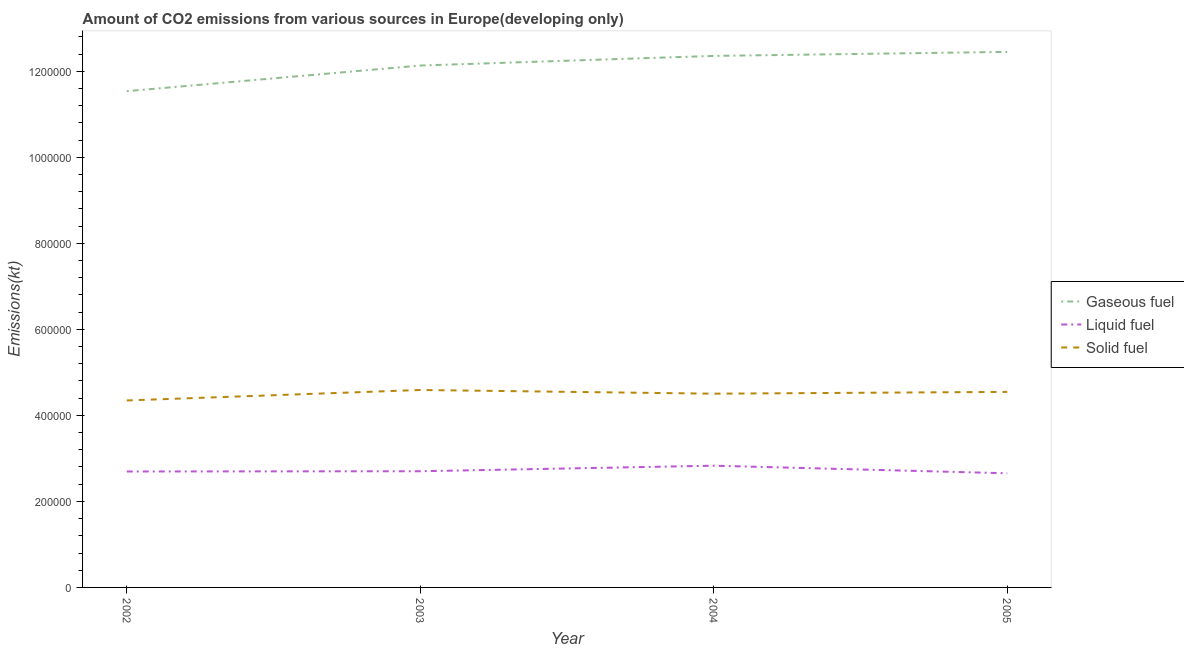Is the number of lines equal to the number of legend labels?
Make the answer very short. Yes. What is the amount of co2 emissions from solid fuel in 2004?
Your response must be concise. 4.50e+05. Across all years, what is the maximum amount of co2 emissions from liquid fuel?
Ensure brevity in your answer.  2.83e+05. Across all years, what is the minimum amount of co2 emissions from solid fuel?
Offer a very short reply. 4.35e+05. In which year was the amount of co2 emissions from solid fuel maximum?
Your answer should be very brief. 2003. What is the total amount of co2 emissions from liquid fuel in the graph?
Your answer should be very brief. 1.09e+06. What is the difference between the amount of co2 emissions from liquid fuel in 2002 and that in 2005?
Offer a terse response. 4170.8. What is the difference between the amount of co2 emissions from gaseous fuel in 2004 and the amount of co2 emissions from solid fuel in 2002?
Your answer should be very brief. 8.01e+05. What is the average amount of co2 emissions from solid fuel per year?
Make the answer very short. 4.50e+05. In the year 2005, what is the difference between the amount of co2 emissions from solid fuel and amount of co2 emissions from liquid fuel?
Give a very brief answer. 1.89e+05. What is the ratio of the amount of co2 emissions from solid fuel in 2004 to that in 2005?
Provide a succinct answer. 0.99. Is the amount of co2 emissions from liquid fuel in 2003 less than that in 2005?
Offer a very short reply. No. Is the difference between the amount of co2 emissions from solid fuel in 2004 and 2005 greater than the difference between the amount of co2 emissions from liquid fuel in 2004 and 2005?
Make the answer very short. No. What is the difference between the highest and the second highest amount of co2 emissions from solid fuel?
Offer a terse response. 4414.18. What is the difference between the highest and the lowest amount of co2 emissions from gaseous fuel?
Offer a terse response. 9.13e+04. Is the amount of co2 emissions from solid fuel strictly greater than the amount of co2 emissions from liquid fuel over the years?
Provide a short and direct response. Yes. Is the amount of co2 emissions from liquid fuel strictly less than the amount of co2 emissions from solid fuel over the years?
Make the answer very short. Yes. What is the difference between two consecutive major ticks on the Y-axis?
Offer a terse response. 2.00e+05. Where does the legend appear in the graph?
Ensure brevity in your answer.  Center right. What is the title of the graph?
Your answer should be compact. Amount of CO2 emissions from various sources in Europe(developing only). Does "Other sectors" appear as one of the legend labels in the graph?
Provide a short and direct response. No. What is the label or title of the X-axis?
Your response must be concise. Year. What is the label or title of the Y-axis?
Your answer should be very brief. Emissions(kt). What is the Emissions(kt) of Gaseous fuel in 2002?
Offer a terse response. 1.15e+06. What is the Emissions(kt) of Liquid fuel in 2002?
Make the answer very short. 2.70e+05. What is the Emissions(kt) in Solid fuel in 2002?
Offer a terse response. 4.35e+05. What is the Emissions(kt) of Gaseous fuel in 2003?
Keep it short and to the point. 1.21e+06. What is the Emissions(kt) in Liquid fuel in 2003?
Offer a very short reply. 2.70e+05. What is the Emissions(kt) of Solid fuel in 2003?
Make the answer very short. 4.59e+05. What is the Emissions(kt) of Gaseous fuel in 2004?
Keep it short and to the point. 1.24e+06. What is the Emissions(kt) in Liquid fuel in 2004?
Provide a short and direct response. 2.83e+05. What is the Emissions(kt) in Solid fuel in 2004?
Keep it short and to the point. 4.50e+05. What is the Emissions(kt) in Gaseous fuel in 2005?
Ensure brevity in your answer.  1.25e+06. What is the Emissions(kt) in Liquid fuel in 2005?
Give a very brief answer. 2.65e+05. What is the Emissions(kt) of Solid fuel in 2005?
Provide a short and direct response. 4.55e+05. Across all years, what is the maximum Emissions(kt) of Gaseous fuel?
Offer a very short reply. 1.25e+06. Across all years, what is the maximum Emissions(kt) of Liquid fuel?
Offer a very short reply. 2.83e+05. Across all years, what is the maximum Emissions(kt) of Solid fuel?
Make the answer very short. 4.59e+05. Across all years, what is the minimum Emissions(kt) in Gaseous fuel?
Your response must be concise. 1.15e+06. Across all years, what is the minimum Emissions(kt) of Liquid fuel?
Provide a short and direct response. 2.65e+05. Across all years, what is the minimum Emissions(kt) of Solid fuel?
Offer a very short reply. 4.35e+05. What is the total Emissions(kt) of Gaseous fuel in the graph?
Give a very brief answer. 4.85e+06. What is the total Emissions(kt) of Liquid fuel in the graph?
Ensure brevity in your answer.  1.09e+06. What is the total Emissions(kt) of Solid fuel in the graph?
Give a very brief answer. 1.80e+06. What is the difference between the Emissions(kt) in Gaseous fuel in 2002 and that in 2003?
Your answer should be compact. -5.96e+04. What is the difference between the Emissions(kt) in Liquid fuel in 2002 and that in 2003?
Keep it short and to the point. -564.24. What is the difference between the Emissions(kt) of Solid fuel in 2002 and that in 2003?
Give a very brief answer. -2.43e+04. What is the difference between the Emissions(kt) in Gaseous fuel in 2002 and that in 2004?
Give a very brief answer. -8.20e+04. What is the difference between the Emissions(kt) of Liquid fuel in 2002 and that in 2004?
Ensure brevity in your answer.  -1.35e+04. What is the difference between the Emissions(kt) in Solid fuel in 2002 and that in 2004?
Your answer should be compact. -1.58e+04. What is the difference between the Emissions(kt) of Gaseous fuel in 2002 and that in 2005?
Make the answer very short. -9.13e+04. What is the difference between the Emissions(kt) of Liquid fuel in 2002 and that in 2005?
Ensure brevity in your answer.  4170.8. What is the difference between the Emissions(kt) of Solid fuel in 2002 and that in 2005?
Offer a very short reply. -1.99e+04. What is the difference between the Emissions(kt) of Gaseous fuel in 2003 and that in 2004?
Make the answer very short. -2.24e+04. What is the difference between the Emissions(kt) in Liquid fuel in 2003 and that in 2004?
Provide a short and direct response. -1.29e+04. What is the difference between the Emissions(kt) of Solid fuel in 2003 and that in 2004?
Your answer should be very brief. 8589.65. What is the difference between the Emissions(kt) of Gaseous fuel in 2003 and that in 2005?
Offer a terse response. -3.17e+04. What is the difference between the Emissions(kt) of Liquid fuel in 2003 and that in 2005?
Keep it short and to the point. 4735.04. What is the difference between the Emissions(kt) in Solid fuel in 2003 and that in 2005?
Provide a succinct answer. 4414.18. What is the difference between the Emissions(kt) in Gaseous fuel in 2004 and that in 2005?
Your response must be concise. -9315.59. What is the difference between the Emissions(kt) of Liquid fuel in 2004 and that in 2005?
Your answer should be very brief. 1.76e+04. What is the difference between the Emissions(kt) of Solid fuel in 2004 and that in 2005?
Offer a very short reply. -4175.47. What is the difference between the Emissions(kt) in Gaseous fuel in 2002 and the Emissions(kt) in Liquid fuel in 2003?
Give a very brief answer. 8.84e+05. What is the difference between the Emissions(kt) of Gaseous fuel in 2002 and the Emissions(kt) of Solid fuel in 2003?
Ensure brevity in your answer.  6.95e+05. What is the difference between the Emissions(kt) in Liquid fuel in 2002 and the Emissions(kt) in Solid fuel in 2003?
Offer a very short reply. -1.89e+05. What is the difference between the Emissions(kt) of Gaseous fuel in 2002 and the Emissions(kt) of Liquid fuel in 2004?
Offer a terse response. 8.71e+05. What is the difference between the Emissions(kt) in Gaseous fuel in 2002 and the Emissions(kt) in Solid fuel in 2004?
Ensure brevity in your answer.  7.03e+05. What is the difference between the Emissions(kt) of Liquid fuel in 2002 and the Emissions(kt) of Solid fuel in 2004?
Offer a terse response. -1.81e+05. What is the difference between the Emissions(kt) of Gaseous fuel in 2002 and the Emissions(kt) of Liquid fuel in 2005?
Your answer should be compact. 8.88e+05. What is the difference between the Emissions(kt) in Gaseous fuel in 2002 and the Emissions(kt) in Solid fuel in 2005?
Provide a short and direct response. 6.99e+05. What is the difference between the Emissions(kt) in Liquid fuel in 2002 and the Emissions(kt) in Solid fuel in 2005?
Provide a short and direct response. -1.85e+05. What is the difference between the Emissions(kt) of Gaseous fuel in 2003 and the Emissions(kt) of Liquid fuel in 2004?
Your response must be concise. 9.30e+05. What is the difference between the Emissions(kt) in Gaseous fuel in 2003 and the Emissions(kt) in Solid fuel in 2004?
Offer a very short reply. 7.63e+05. What is the difference between the Emissions(kt) of Liquid fuel in 2003 and the Emissions(kt) of Solid fuel in 2004?
Your answer should be very brief. -1.80e+05. What is the difference between the Emissions(kt) in Gaseous fuel in 2003 and the Emissions(kt) in Liquid fuel in 2005?
Your answer should be compact. 9.48e+05. What is the difference between the Emissions(kt) in Gaseous fuel in 2003 and the Emissions(kt) in Solid fuel in 2005?
Make the answer very short. 7.59e+05. What is the difference between the Emissions(kt) in Liquid fuel in 2003 and the Emissions(kt) in Solid fuel in 2005?
Offer a terse response. -1.84e+05. What is the difference between the Emissions(kt) of Gaseous fuel in 2004 and the Emissions(kt) of Liquid fuel in 2005?
Ensure brevity in your answer.  9.70e+05. What is the difference between the Emissions(kt) in Gaseous fuel in 2004 and the Emissions(kt) in Solid fuel in 2005?
Offer a terse response. 7.81e+05. What is the difference between the Emissions(kt) in Liquid fuel in 2004 and the Emissions(kt) in Solid fuel in 2005?
Offer a very short reply. -1.72e+05. What is the average Emissions(kt) in Gaseous fuel per year?
Offer a terse response. 1.21e+06. What is the average Emissions(kt) of Liquid fuel per year?
Keep it short and to the point. 2.72e+05. What is the average Emissions(kt) of Solid fuel per year?
Give a very brief answer. 4.50e+05. In the year 2002, what is the difference between the Emissions(kt) of Gaseous fuel and Emissions(kt) of Liquid fuel?
Ensure brevity in your answer.  8.84e+05. In the year 2002, what is the difference between the Emissions(kt) in Gaseous fuel and Emissions(kt) in Solid fuel?
Provide a short and direct response. 7.19e+05. In the year 2002, what is the difference between the Emissions(kt) in Liquid fuel and Emissions(kt) in Solid fuel?
Ensure brevity in your answer.  -1.65e+05. In the year 2003, what is the difference between the Emissions(kt) in Gaseous fuel and Emissions(kt) in Liquid fuel?
Your answer should be compact. 9.43e+05. In the year 2003, what is the difference between the Emissions(kt) in Gaseous fuel and Emissions(kt) in Solid fuel?
Provide a succinct answer. 7.54e+05. In the year 2003, what is the difference between the Emissions(kt) in Liquid fuel and Emissions(kt) in Solid fuel?
Keep it short and to the point. -1.89e+05. In the year 2004, what is the difference between the Emissions(kt) of Gaseous fuel and Emissions(kt) of Liquid fuel?
Provide a succinct answer. 9.53e+05. In the year 2004, what is the difference between the Emissions(kt) of Gaseous fuel and Emissions(kt) of Solid fuel?
Make the answer very short. 7.85e+05. In the year 2004, what is the difference between the Emissions(kt) of Liquid fuel and Emissions(kt) of Solid fuel?
Provide a short and direct response. -1.67e+05. In the year 2005, what is the difference between the Emissions(kt) in Gaseous fuel and Emissions(kt) in Liquid fuel?
Offer a very short reply. 9.80e+05. In the year 2005, what is the difference between the Emissions(kt) of Gaseous fuel and Emissions(kt) of Solid fuel?
Offer a terse response. 7.90e+05. In the year 2005, what is the difference between the Emissions(kt) in Liquid fuel and Emissions(kt) in Solid fuel?
Keep it short and to the point. -1.89e+05. What is the ratio of the Emissions(kt) in Gaseous fuel in 2002 to that in 2003?
Your response must be concise. 0.95. What is the ratio of the Emissions(kt) of Solid fuel in 2002 to that in 2003?
Make the answer very short. 0.95. What is the ratio of the Emissions(kt) in Gaseous fuel in 2002 to that in 2004?
Keep it short and to the point. 0.93. What is the ratio of the Emissions(kt) in Liquid fuel in 2002 to that in 2004?
Provide a short and direct response. 0.95. What is the ratio of the Emissions(kt) in Solid fuel in 2002 to that in 2004?
Offer a terse response. 0.96. What is the ratio of the Emissions(kt) of Gaseous fuel in 2002 to that in 2005?
Offer a terse response. 0.93. What is the ratio of the Emissions(kt) in Liquid fuel in 2002 to that in 2005?
Ensure brevity in your answer.  1.02. What is the ratio of the Emissions(kt) of Solid fuel in 2002 to that in 2005?
Your answer should be compact. 0.96. What is the ratio of the Emissions(kt) of Gaseous fuel in 2003 to that in 2004?
Ensure brevity in your answer.  0.98. What is the ratio of the Emissions(kt) in Liquid fuel in 2003 to that in 2004?
Give a very brief answer. 0.95. What is the ratio of the Emissions(kt) in Solid fuel in 2003 to that in 2004?
Keep it short and to the point. 1.02. What is the ratio of the Emissions(kt) of Gaseous fuel in 2003 to that in 2005?
Keep it short and to the point. 0.97. What is the ratio of the Emissions(kt) in Liquid fuel in 2003 to that in 2005?
Your answer should be compact. 1.02. What is the ratio of the Emissions(kt) of Solid fuel in 2003 to that in 2005?
Give a very brief answer. 1.01. What is the ratio of the Emissions(kt) in Liquid fuel in 2004 to that in 2005?
Offer a terse response. 1.07. What is the difference between the highest and the second highest Emissions(kt) of Gaseous fuel?
Ensure brevity in your answer.  9315.59. What is the difference between the highest and the second highest Emissions(kt) in Liquid fuel?
Ensure brevity in your answer.  1.29e+04. What is the difference between the highest and the second highest Emissions(kt) in Solid fuel?
Provide a short and direct response. 4414.18. What is the difference between the highest and the lowest Emissions(kt) in Gaseous fuel?
Your response must be concise. 9.13e+04. What is the difference between the highest and the lowest Emissions(kt) of Liquid fuel?
Provide a short and direct response. 1.76e+04. What is the difference between the highest and the lowest Emissions(kt) in Solid fuel?
Give a very brief answer. 2.43e+04. 